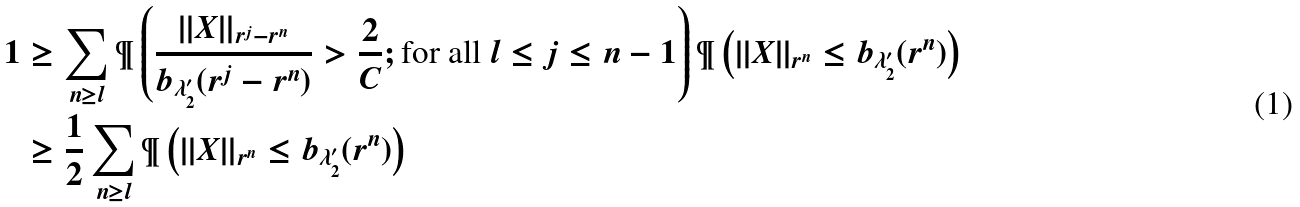<formula> <loc_0><loc_0><loc_500><loc_500>1 & \geq \sum _ { n \geq l } \P \left ( \frac { | | X | | _ { r ^ { j } - r ^ { n } } } { b _ { \lambda _ { 2 } ^ { \prime } } ( r ^ { j } - r ^ { n } ) } > \frac { 2 } { C } ; \text {for all $l\leq j\leq n-1$} \right ) \P \left ( | | X | | _ { r ^ { n } } \leq b _ { \lambda _ { 2 } ^ { \prime } } ( r ^ { n } ) \right ) \\ & \geq \frac { 1 } { 2 } \sum _ { n \geq l } \P \left ( | | X | | _ { r ^ { n } } \leq b _ { \lambda _ { 2 } ^ { \prime } } ( r ^ { n } ) \right )</formula> 